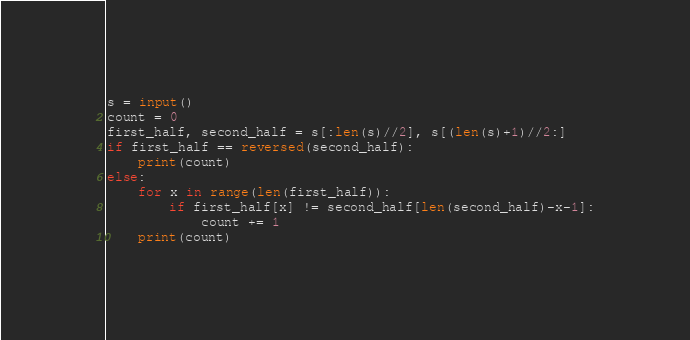Convert code to text. <code><loc_0><loc_0><loc_500><loc_500><_Python_>s = input()
count = 0
first_half, second_half = s[:len(s)//2], s[(len(s)+1)//2:]
if first_half == reversed(second_half):
    print(count)
else:
    for x in range(len(first_half)):
        if first_half[x] != second_half[len(second_half)-x-1]:
            count += 1
    print(count)</code> 